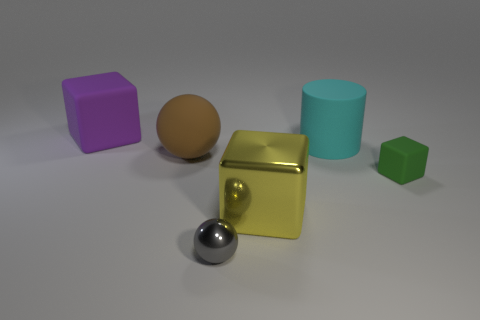Subtract all purple matte cubes. How many cubes are left? 2 Add 3 small purple rubber objects. How many objects exist? 9 Subtract all spheres. How many objects are left? 4 Subtract all purple blocks. How many blocks are left? 2 Subtract all yellow spheres. How many purple cubes are left? 1 Subtract all green matte things. Subtract all cylinders. How many objects are left? 4 Add 5 green blocks. How many green blocks are left? 6 Add 5 tiny yellow things. How many tiny yellow things exist? 5 Subtract 0 green cylinders. How many objects are left? 6 Subtract 2 cubes. How many cubes are left? 1 